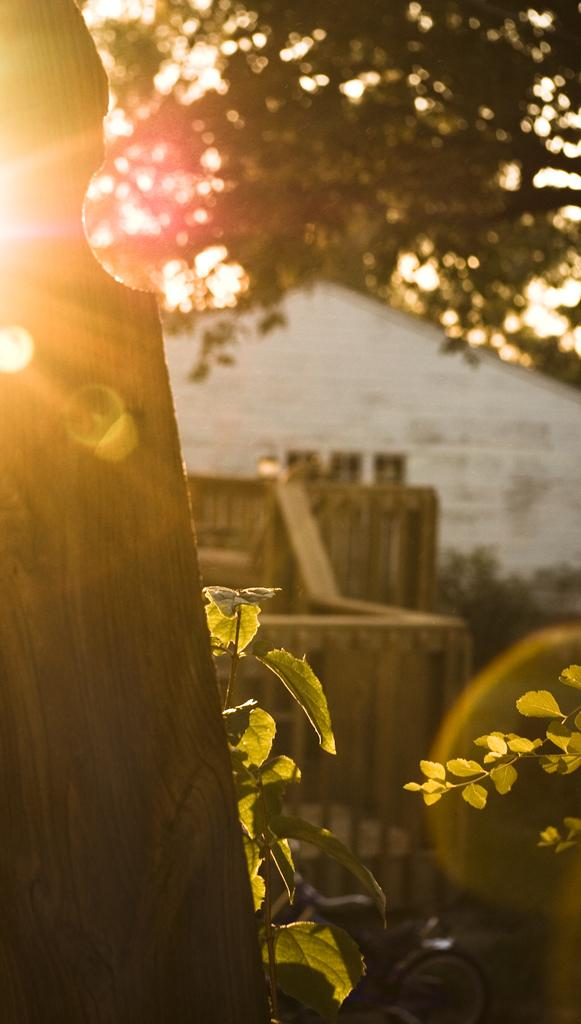Where was the image taken? The image was clicked outside. What can be seen at the top of the image? There is a tree at the top of the image. What is present at the bottom of the image? There are plants at the bottom of the image. What type of yak is grazing on the plants at the bottom of the image? There is no yak present in the image; it only features a tree and plants. Who is the partner of the person taking the picture in the image? The image does not show any people, so there is no partner present. 